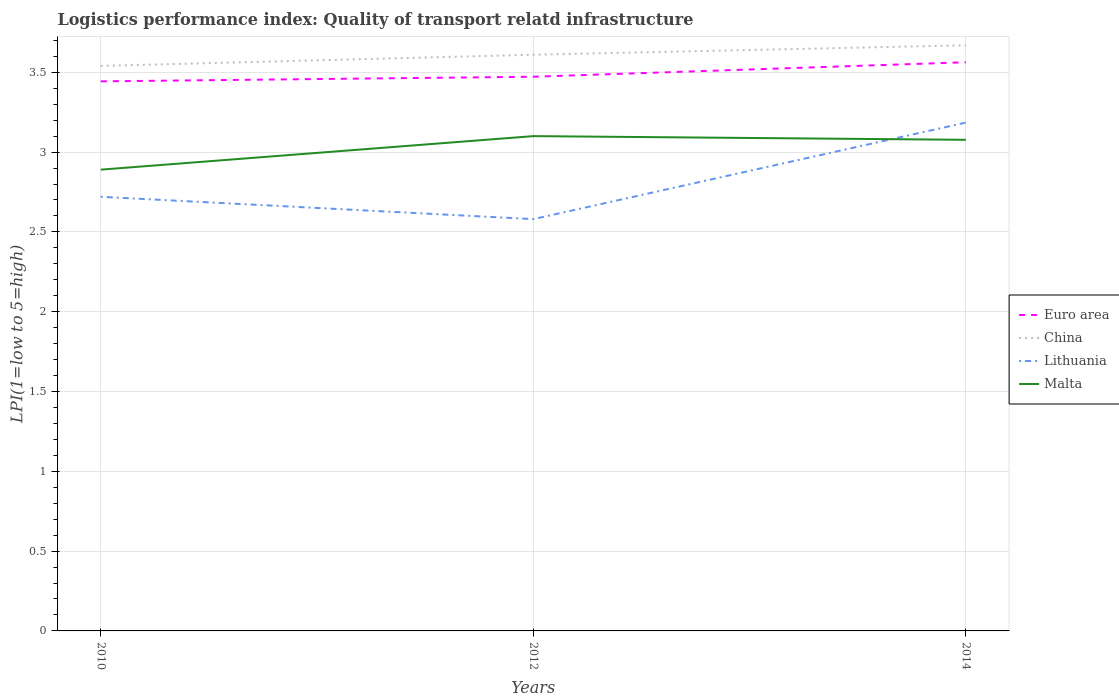Is the number of lines equal to the number of legend labels?
Your answer should be compact. Yes. Across all years, what is the maximum logistics performance index in Euro area?
Provide a succinct answer. 3.44. In which year was the logistics performance index in Lithuania maximum?
Make the answer very short. 2012. What is the total logistics performance index in Lithuania in the graph?
Provide a short and direct response. -0.46. What is the difference between the highest and the second highest logistics performance index in Malta?
Provide a succinct answer. 0.21. Is the logistics performance index in China strictly greater than the logistics performance index in Malta over the years?
Keep it short and to the point. No. What is the difference between two consecutive major ticks on the Y-axis?
Provide a short and direct response. 0.5. Are the values on the major ticks of Y-axis written in scientific E-notation?
Offer a terse response. No. Where does the legend appear in the graph?
Your answer should be compact. Center right. How are the legend labels stacked?
Offer a very short reply. Vertical. What is the title of the graph?
Provide a short and direct response. Logistics performance index: Quality of transport relatd infrastructure. Does "United Arab Emirates" appear as one of the legend labels in the graph?
Ensure brevity in your answer.  No. What is the label or title of the Y-axis?
Keep it short and to the point. LPI(1=low to 5=high). What is the LPI(1=low to 5=high) of Euro area in 2010?
Your response must be concise. 3.44. What is the LPI(1=low to 5=high) in China in 2010?
Your answer should be compact. 3.54. What is the LPI(1=low to 5=high) of Lithuania in 2010?
Your answer should be very brief. 2.72. What is the LPI(1=low to 5=high) in Malta in 2010?
Provide a succinct answer. 2.89. What is the LPI(1=low to 5=high) in Euro area in 2012?
Keep it short and to the point. 3.47. What is the LPI(1=low to 5=high) in China in 2012?
Give a very brief answer. 3.61. What is the LPI(1=low to 5=high) in Lithuania in 2012?
Keep it short and to the point. 2.58. What is the LPI(1=low to 5=high) in Euro area in 2014?
Offer a terse response. 3.56. What is the LPI(1=low to 5=high) in China in 2014?
Make the answer very short. 3.67. What is the LPI(1=low to 5=high) in Lithuania in 2014?
Offer a very short reply. 3.18. What is the LPI(1=low to 5=high) of Malta in 2014?
Your answer should be very brief. 3.08. Across all years, what is the maximum LPI(1=low to 5=high) in Euro area?
Your answer should be compact. 3.56. Across all years, what is the maximum LPI(1=low to 5=high) of China?
Your answer should be very brief. 3.67. Across all years, what is the maximum LPI(1=low to 5=high) of Lithuania?
Give a very brief answer. 3.18. Across all years, what is the maximum LPI(1=low to 5=high) of Malta?
Ensure brevity in your answer.  3.1. Across all years, what is the minimum LPI(1=low to 5=high) in Euro area?
Ensure brevity in your answer.  3.44. Across all years, what is the minimum LPI(1=low to 5=high) in China?
Your answer should be very brief. 3.54. Across all years, what is the minimum LPI(1=low to 5=high) of Lithuania?
Give a very brief answer. 2.58. Across all years, what is the minimum LPI(1=low to 5=high) of Malta?
Your answer should be compact. 2.89. What is the total LPI(1=low to 5=high) in Euro area in the graph?
Keep it short and to the point. 10.48. What is the total LPI(1=low to 5=high) in China in the graph?
Your answer should be compact. 10.82. What is the total LPI(1=low to 5=high) of Lithuania in the graph?
Your answer should be compact. 8.48. What is the total LPI(1=low to 5=high) of Malta in the graph?
Offer a very short reply. 9.07. What is the difference between the LPI(1=low to 5=high) of Euro area in 2010 and that in 2012?
Give a very brief answer. -0.03. What is the difference between the LPI(1=low to 5=high) in China in 2010 and that in 2012?
Make the answer very short. -0.07. What is the difference between the LPI(1=low to 5=high) of Lithuania in 2010 and that in 2012?
Give a very brief answer. 0.14. What is the difference between the LPI(1=low to 5=high) of Malta in 2010 and that in 2012?
Your answer should be very brief. -0.21. What is the difference between the LPI(1=low to 5=high) in Euro area in 2010 and that in 2014?
Ensure brevity in your answer.  -0.12. What is the difference between the LPI(1=low to 5=high) in China in 2010 and that in 2014?
Your answer should be very brief. -0.13. What is the difference between the LPI(1=low to 5=high) of Lithuania in 2010 and that in 2014?
Make the answer very short. -0.46. What is the difference between the LPI(1=low to 5=high) in Malta in 2010 and that in 2014?
Your answer should be very brief. -0.19. What is the difference between the LPI(1=low to 5=high) in Euro area in 2012 and that in 2014?
Keep it short and to the point. -0.09. What is the difference between the LPI(1=low to 5=high) in China in 2012 and that in 2014?
Keep it short and to the point. -0.06. What is the difference between the LPI(1=low to 5=high) in Lithuania in 2012 and that in 2014?
Give a very brief answer. -0.6. What is the difference between the LPI(1=low to 5=high) in Malta in 2012 and that in 2014?
Your response must be concise. 0.02. What is the difference between the LPI(1=low to 5=high) of Euro area in 2010 and the LPI(1=low to 5=high) of China in 2012?
Keep it short and to the point. -0.17. What is the difference between the LPI(1=low to 5=high) of Euro area in 2010 and the LPI(1=low to 5=high) of Lithuania in 2012?
Offer a terse response. 0.86. What is the difference between the LPI(1=low to 5=high) in Euro area in 2010 and the LPI(1=low to 5=high) in Malta in 2012?
Offer a very short reply. 0.34. What is the difference between the LPI(1=low to 5=high) in China in 2010 and the LPI(1=low to 5=high) in Lithuania in 2012?
Provide a succinct answer. 0.96. What is the difference between the LPI(1=low to 5=high) in China in 2010 and the LPI(1=low to 5=high) in Malta in 2012?
Offer a very short reply. 0.44. What is the difference between the LPI(1=low to 5=high) of Lithuania in 2010 and the LPI(1=low to 5=high) of Malta in 2012?
Give a very brief answer. -0.38. What is the difference between the LPI(1=low to 5=high) of Euro area in 2010 and the LPI(1=low to 5=high) of China in 2014?
Keep it short and to the point. -0.23. What is the difference between the LPI(1=low to 5=high) of Euro area in 2010 and the LPI(1=low to 5=high) of Lithuania in 2014?
Keep it short and to the point. 0.26. What is the difference between the LPI(1=low to 5=high) of Euro area in 2010 and the LPI(1=low to 5=high) of Malta in 2014?
Your answer should be compact. 0.37. What is the difference between the LPI(1=low to 5=high) of China in 2010 and the LPI(1=low to 5=high) of Lithuania in 2014?
Provide a succinct answer. 0.36. What is the difference between the LPI(1=low to 5=high) in China in 2010 and the LPI(1=low to 5=high) in Malta in 2014?
Your answer should be very brief. 0.46. What is the difference between the LPI(1=low to 5=high) in Lithuania in 2010 and the LPI(1=low to 5=high) in Malta in 2014?
Offer a terse response. -0.36. What is the difference between the LPI(1=low to 5=high) in Euro area in 2012 and the LPI(1=low to 5=high) in China in 2014?
Offer a terse response. -0.2. What is the difference between the LPI(1=low to 5=high) of Euro area in 2012 and the LPI(1=low to 5=high) of Lithuania in 2014?
Provide a succinct answer. 0.29. What is the difference between the LPI(1=low to 5=high) of Euro area in 2012 and the LPI(1=low to 5=high) of Malta in 2014?
Provide a short and direct response. 0.4. What is the difference between the LPI(1=low to 5=high) of China in 2012 and the LPI(1=low to 5=high) of Lithuania in 2014?
Keep it short and to the point. 0.43. What is the difference between the LPI(1=low to 5=high) in China in 2012 and the LPI(1=low to 5=high) in Malta in 2014?
Give a very brief answer. 0.53. What is the difference between the LPI(1=low to 5=high) of Lithuania in 2012 and the LPI(1=low to 5=high) of Malta in 2014?
Provide a succinct answer. -0.5. What is the average LPI(1=low to 5=high) in Euro area per year?
Offer a terse response. 3.49. What is the average LPI(1=low to 5=high) in China per year?
Ensure brevity in your answer.  3.61. What is the average LPI(1=low to 5=high) in Lithuania per year?
Keep it short and to the point. 2.83. What is the average LPI(1=low to 5=high) of Malta per year?
Your answer should be compact. 3.02. In the year 2010, what is the difference between the LPI(1=low to 5=high) of Euro area and LPI(1=low to 5=high) of China?
Keep it short and to the point. -0.1. In the year 2010, what is the difference between the LPI(1=low to 5=high) in Euro area and LPI(1=low to 5=high) in Lithuania?
Give a very brief answer. 0.72. In the year 2010, what is the difference between the LPI(1=low to 5=high) in Euro area and LPI(1=low to 5=high) in Malta?
Make the answer very short. 0.55. In the year 2010, what is the difference between the LPI(1=low to 5=high) in China and LPI(1=low to 5=high) in Lithuania?
Your response must be concise. 0.82. In the year 2010, what is the difference between the LPI(1=low to 5=high) of China and LPI(1=low to 5=high) of Malta?
Keep it short and to the point. 0.65. In the year 2010, what is the difference between the LPI(1=low to 5=high) of Lithuania and LPI(1=low to 5=high) of Malta?
Your response must be concise. -0.17. In the year 2012, what is the difference between the LPI(1=low to 5=high) in Euro area and LPI(1=low to 5=high) in China?
Keep it short and to the point. -0.14. In the year 2012, what is the difference between the LPI(1=low to 5=high) of Euro area and LPI(1=low to 5=high) of Lithuania?
Make the answer very short. 0.89. In the year 2012, what is the difference between the LPI(1=low to 5=high) of Euro area and LPI(1=low to 5=high) of Malta?
Keep it short and to the point. 0.37. In the year 2012, what is the difference between the LPI(1=low to 5=high) in China and LPI(1=low to 5=high) in Lithuania?
Keep it short and to the point. 1.03. In the year 2012, what is the difference between the LPI(1=low to 5=high) of China and LPI(1=low to 5=high) of Malta?
Provide a succinct answer. 0.51. In the year 2012, what is the difference between the LPI(1=low to 5=high) in Lithuania and LPI(1=low to 5=high) in Malta?
Your answer should be compact. -0.52. In the year 2014, what is the difference between the LPI(1=low to 5=high) in Euro area and LPI(1=low to 5=high) in China?
Ensure brevity in your answer.  -0.11. In the year 2014, what is the difference between the LPI(1=low to 5=high) in Euro area and LPI(1=low to 5=high) in Lithuania?
Provide a short and direct response. 0.38. In the year 2014, what is the difference between the LPI(1=low to 5=high) in Euro area and LPI(1=low to 5=high) in Malta?
Your answer should be compact. 0.49. In the year 2014, what is the difference between the LPI(1=low to 5=high) in China and LPI(1=low to 5=high) in Lithuania?
Your answer should be very brief. 0.48. In the year 2014, what is the difference between the LPI(1=low to 5=high) in China and LPI(1=low to 5=high) in Malta?
Ensure brevity in your answer.  0.59. In the year 2014, what is the difference between the LPI(1=low to 5=high) of Lithuania and LPI(1=low to 5=high) of Malta?
Your answer should be compact. 0.11. What is the ratio of the LPI(1=low to 5=high) of China in 2010 to that in 2012?
Give a very brief answer. 0.98. What is the ratio of the LPI(1=low to 5=high) of Lithuania in 2010 to that in 2012?
Provide a succinct answer. 1.05. What is the ratio of the LPI(1=low to 5=high) in Malta in 2010 to that in 2012?
Your answer should be very brief. 0.93. What is the ratio of the LPI(1=low to 5=high) of Euro area in 2010 to that in 2014?
Keep it short and to the point. 0.97. What is the ratio of the LPI(1=low to 5=high) of China in 2010 to that in 2014?
Provide a short and direct response. 0.96. What is the ratio of the LPI(1=low to 5=high) of Lithuania in 2010 to that in 2014?
Make the answer very short. 0.85. What is the ratio of the LPI(1=low to 5=high) of Malta in 2010 to that in 2014?
Give a very brief answer. 0.94. What is the ratio of the LPI(1=low to 5=high) of Euro area in 2012 to that in 2014?
Ensure brevity in your answer.  0.97. What is the ratio of the LPI(1=low to 5=high) of China in 2012 to that in 2014?
Give a very brief answer. 0.98. What is the ratio of the LPI(1=low to 5=high) of Lithuania in 2012 to that in 2014?
Your answer should be very brief. 0.81. What is the ratio of the LPI(1=low to 5=high) of Malta in 2012 to that in 2014?
Your answer should be very brief. 1.01. What is the difference between the highest and the second highest LPI(1=low to 5=high) of Euro area?
Make the answer very short. 0.09. What is the difference between the highest and the second highest LPI(1=low to 5=high) in China?
Your answer should be very brief. 0.06. What is the difference between the highest and the second highest LPI(1=low to 5=high) in Lithuania?
Make the answer very short. 0.46. What is the difference between the highest and the second highest LPI(1=low to 5=high) in Malta?
Offer a very short reply. 0.02. What is the difference between the highest and the lowest LPI(1=low to 5=high) of Euro area?
Keep it short and to the point. 0.12. What is the difference between the highest and the lowest LPI(1=low to 5=high) in China?
Provide a succinct answer. 0.13. What is the difference between the highest and the lowest LPI(1=low to 5=high) in Lithuania?
Keep it short and to the point. 0.6. What is the difference between the highest and the lowest LPI(1=low to 5=high) of Malta?
Ensure brevity in your answer.  0.21. 